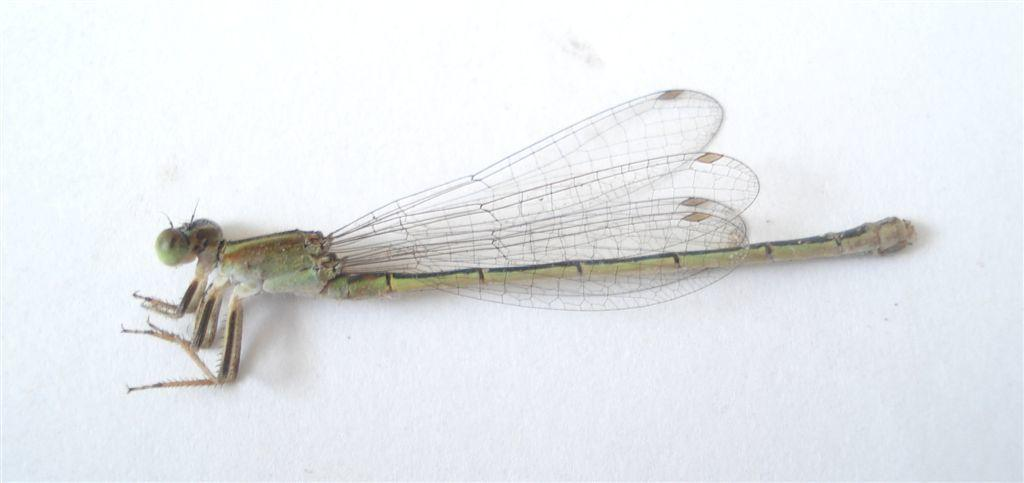What type of insect is present in the image? There is a dragonfly in the image. How many men are working together in the image? There are no men present in the image, as it features a dragonfly. 